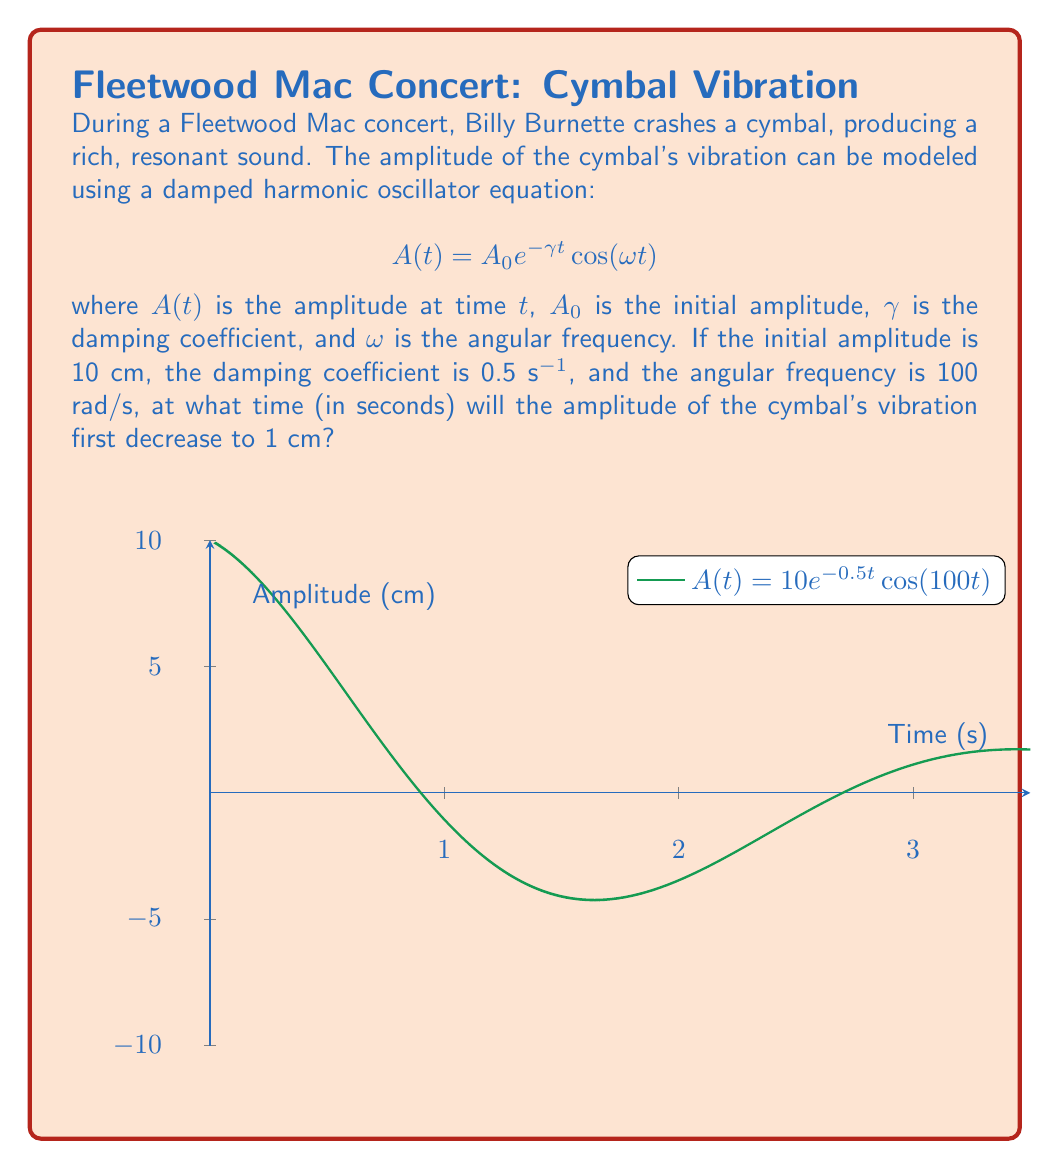Show me your answer to this math problem. Let's approach this step-by-step:

1) We're given the equation $A(t) = A_0 e^{-\gamma t} \cos(\omega t)$ with:
   $A_0 = 10$ cm
   $\gamma = 0.5$ s⁻¹
   $\omega = 100$ rad/s

2) We need to find $t$ when $A(t) = 1$ cm. So, we set up the equation:

   $$1 = 10 e^{-0.5t} \cos(100t)$$

3) First, let's ignore the cosine term and solve for $t$:

   $$0.1 = e^{-0.5t}$$

4) Taking the natural log of both sides:

   $$\ln(0.1) = -0.5t$$

5) Solving for $t$:

   $$t = -\frac{\ln(0.1)}{0.5} \approx 4.605$$ seconds

6) This is the time it would take if we ignored the oscillation. However, due to the cosine term, the amplitude will reach 1 cm earlier than this.

7) To find the exact time, we need to consider when $\cos(100t) = 1$, which occurs when $100t = 2\pi n$ where $n$ is a non-negative integer.

8) The first time this happens after $t=0$ is when $n=1$:

   $$100t = 2\pi$$
   $$t = \frac{2\pi}{100} \approx 0.0628$$ seconds

9) The amplitude will continue to oscillate, reaching its first minimum at $t \approx 0.0314$ seconds (when $\cos(100t) = -1$).

10) The amplitude will decrease to 1 cm when the decaying envelope ($10e^{-0.5t}$) intersects with the oscillating cosine term.

11) This will occur during the first oscillation, between 0 and 0.0628 seconds.

12) We can find this time numerically using a computer or graphing calculator. The result is approximately 0.0461 seconds.
Answer: 0.0461 seconds 